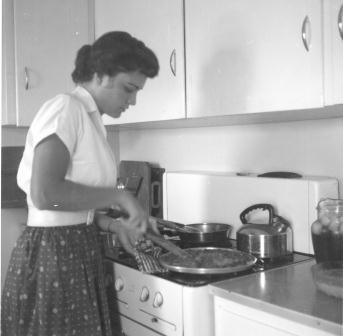Describe the objects in this image and their specific colors. I can see people in white, gray, darkgray, lightgray, and black tones, oven in white, gray, darkgray, lightgray, and black tones, pizza in gray and white tones, and knife in gray, black, and white tones in this image. 